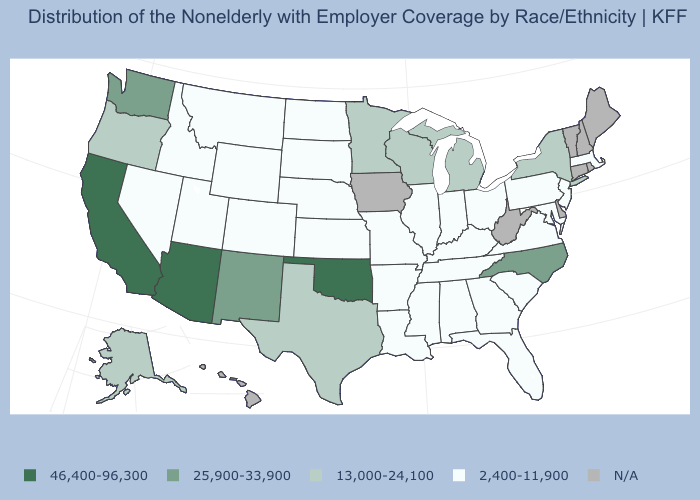Does the first symbol in the legend represent the smallest category?
Short answer required. No. Which states hav the highest value in the West?
Keep it brief. Arizona, California. What is the lowest value in the USA?
Give a very brief answer. 2,400-11,900. What is the value of Vermont?
Quick response, please. N/A. Which states have the lowest value in the MidWest?
Give a very brief answer. Illinois, Indiana, Kansas, Missouri, Nebraska, North Dakota, Ohio, South Dakota. What is the lowest value in the West?
Concise answer only. 2,400-11,900. Does the map have missing data?
Write a very short answer. Yes. What is the lowest value in states that border Nevada?
Answer briefly. 2,400-11,900. What is the highest value in the USA?
Keep it brief. 46,400-96,300. Name the states that have a value in the range 46,400-96,300?
Concise answer only. Arizona, California, Oklahoma. Name the states that have a value in the range 46,400-96,300?
Concise answer only. Arizona, California, Oklahoma. Name the states that have a value in the range 46,400-96,300?
Be succinct. Arizona, California, Oklahoma. Does the map have missing data?
Give a very brief answer. Yes. Name the states that have a value in the range 25,900-33,900?
Answer briefly. New Mexico, North Carolina, Washington. Does Nevada have the lowest value in the USA?
Give a very brief answer. Yes. 